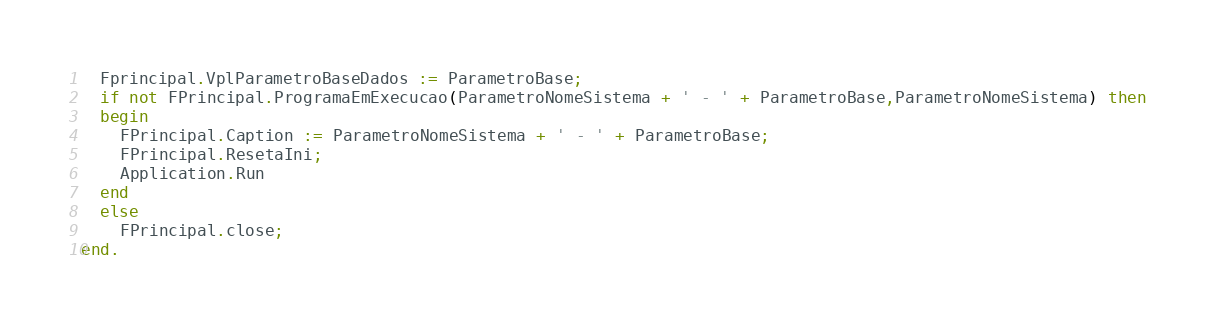<code> <loc_0><loc_0><loc_500><loc_500><_Pascal_>  Fprincipal.VplParametroBaseDados := ParametroBase;
  if not FPrincipal.ProgramaEmExecucao(ParametroNomeSistema + ' - ' + ParametroBase,ParametroNomeSistema) then
  begin
    FPrincipal.Caption := ParametroNomeSistema + ' - ' + ParametroBase;
    FPrincipal.ResetaIni;
    Application.Run
  end
  else
    FPrincipal.close;
end.
</code> 